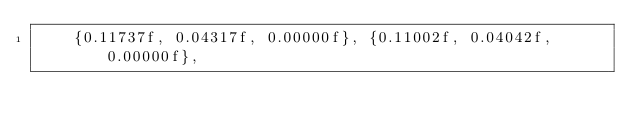<code> <loc_0><loc_0><loc_500><loc_500><_C_>    {0.11737f, 0.04317f, 0.00000f}, {0.11002f, 0.04042f, 0.00000f},</code> 